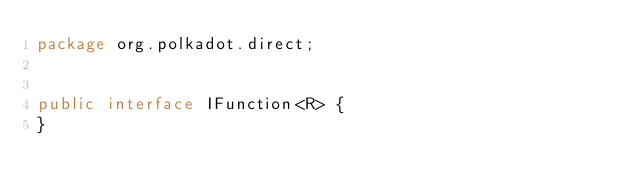<code> <loc_0><loc_0><loc_500><loc_500><_Java_>package org.polkadot.direct;


public interface IFunction<R> {
}
</code> 